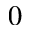<formula> <loc_0><loc_0><loc_500><loc_500>0</formula> 